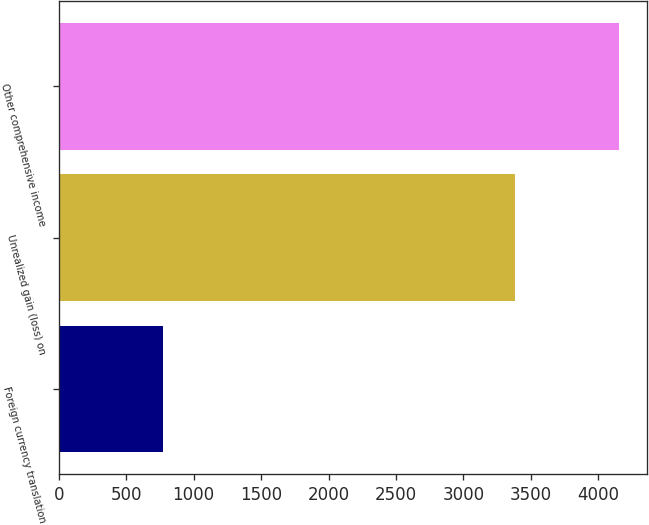<chart> <loc_0><loc_0><loc_500><loc_500><bar_chart><fcel>Foreign currency translation<fcel>Unrealized gain (loss) on<fcel>Other comprehensive income<nl><fcel>776<fcel>3379<fcel>4155<nl></chart> 